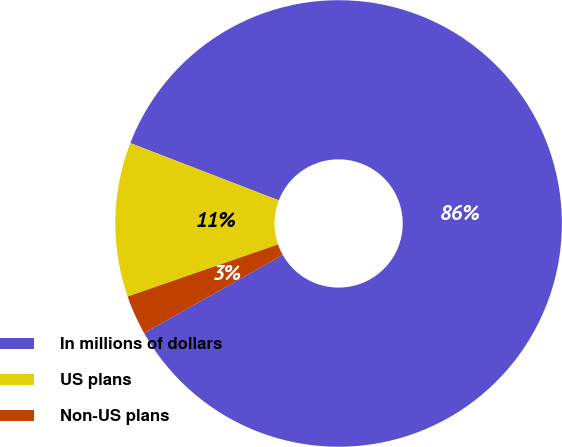Convert chart. <chart><loc_0><loc_0><loc_500><loc_500><pie_chart><fcel>In millions of dollars<fcel>US plans<fcel>Non-US plans<nl><fcel>85.97%<fcel>11.17%<fcel>2.86%<nl></chart> 